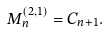<formula> <loc_0><loc_0><loc_500><loc_500>M _ { n } ^ { ( 2 , 1 ) } = C _ { n + 1 } .</formula> 